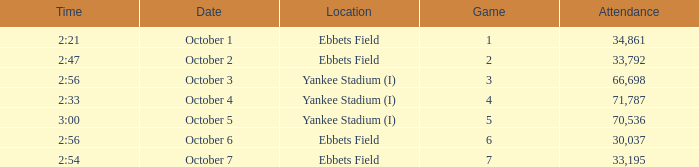Yankee stadium (i), and a time of 3:00 has what attendance for this location? 70536.0. 